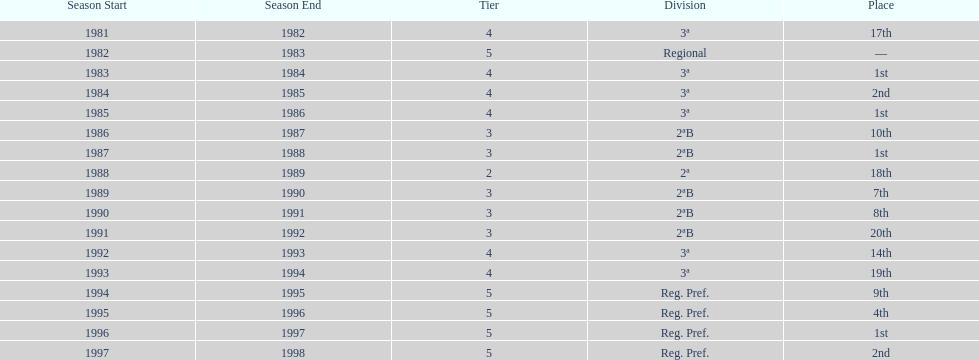What year has no place indicated? 1982/83. 